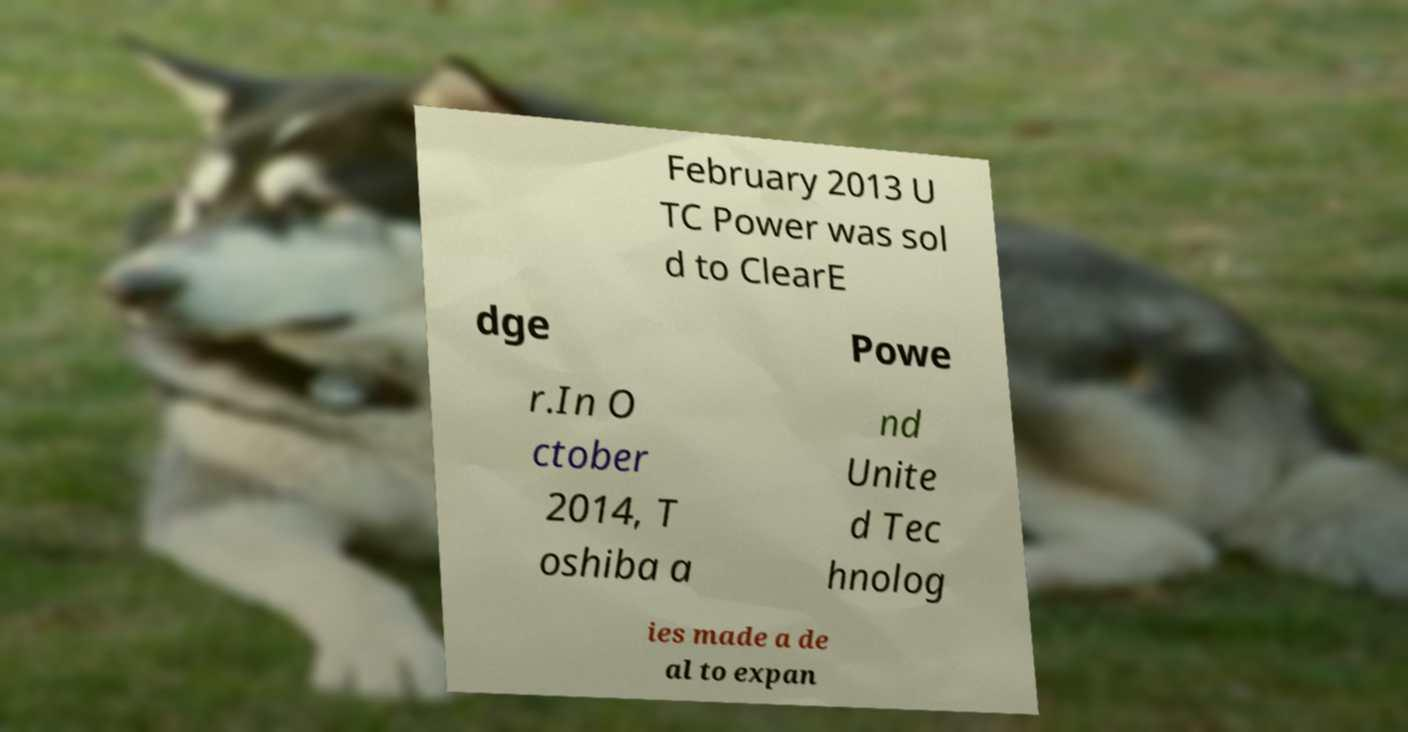For documentation purposes, I need the text within this image transcribed. Could you provide that? February 2013 U TC Power was sol d to ClearE dge Powe r.In O ctober 2014, T oshiba a nd Unite d Tec hnolog ies made a de al to expan 